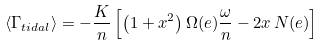Convert formula to latex. <formula><loc_0><loc_0><loc_500><loc_500>\left \langle \Gamma _ { t i d a l } \right \rangle = - \frac { K } { n } \left [ \left ( 1 + x ^ { 2 } \right ) \Omega ( e ) \frac { \omega } { n } - 2 x \, N ( e ) \right ] \,</formula> 